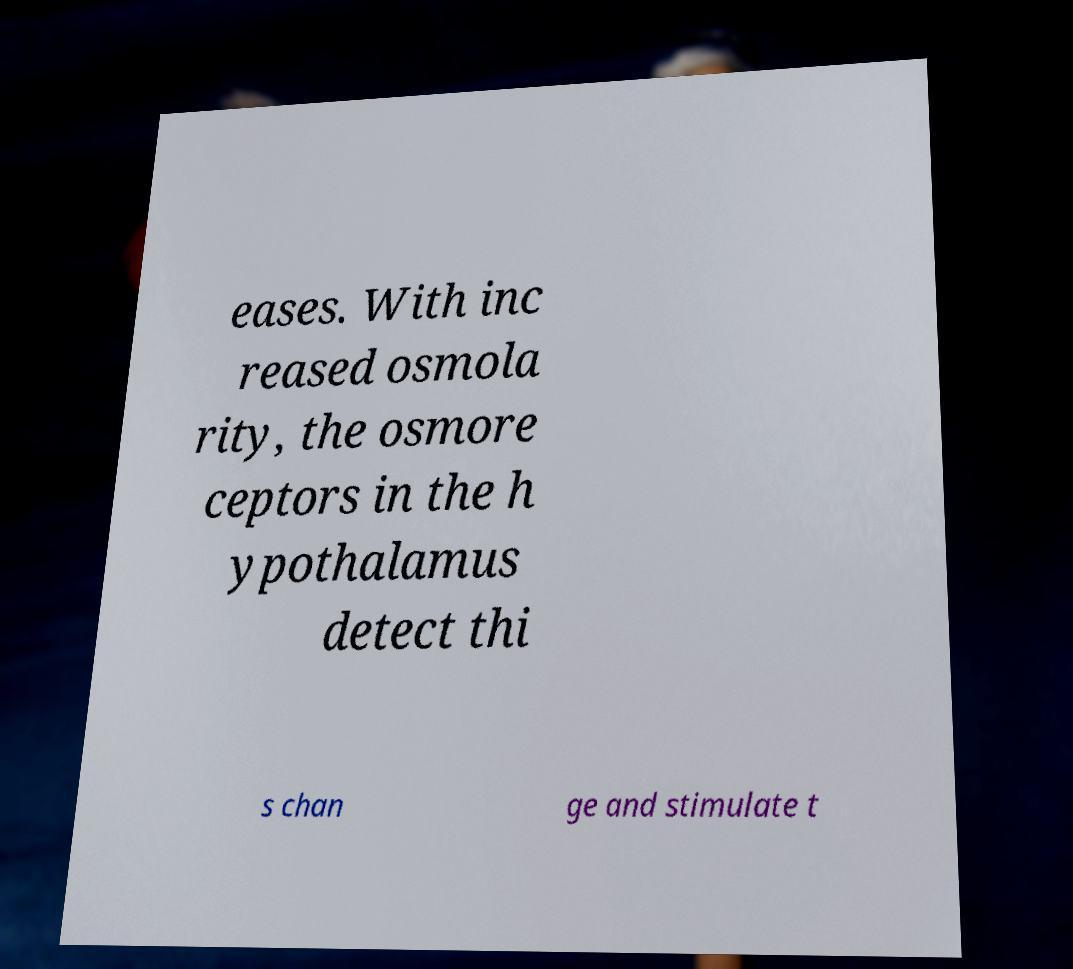Could you extract and type out the text from this image? eases. With inc reased osmola rity, the osmore ceptors in the h ypothalamus detect thi s chan ge and stimulate t 